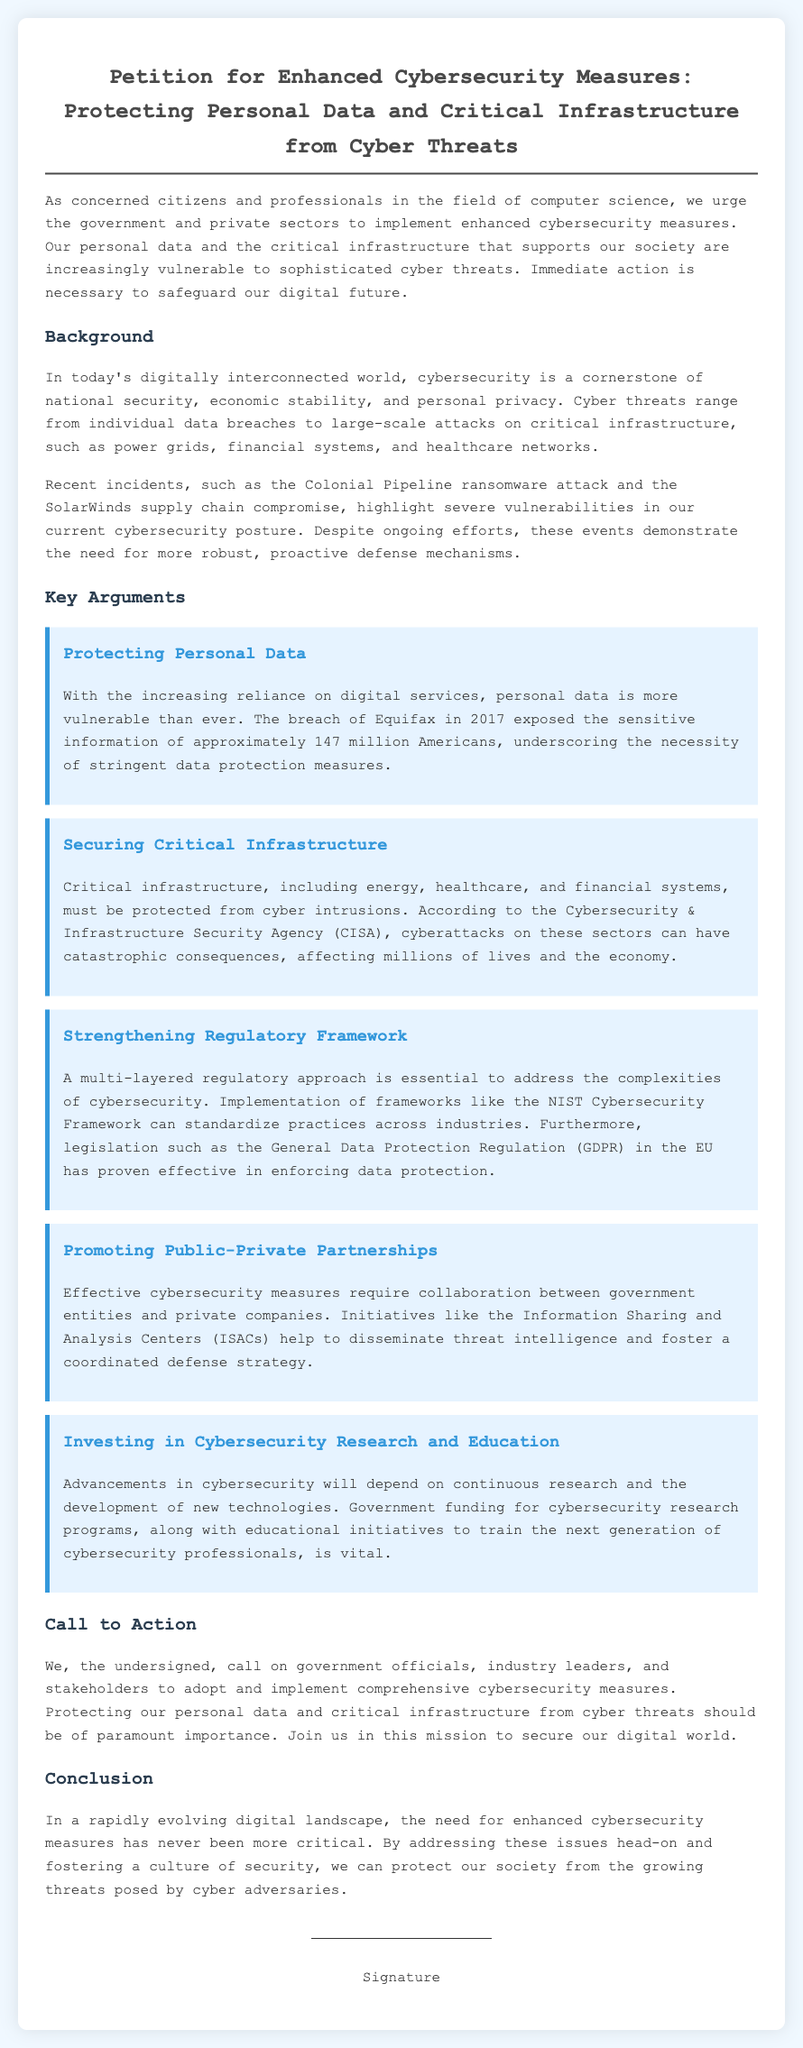What is the title of the petition? The title summarizes the main focus of the document and is stated at the beginning.
Answer: Petition for Enhanced Cybersecurity Measures: Protecting Personal Data and Critical Infrastructure from Cyber Threats What is one recent incident mentioned? The document provides examples of what has highlighted cybersecurity vulnerabilities.
Answer: Colonial Pipeline ransomware attack How many Americans were affected by the Equifax breach? This number illustrates the significant impact of the data breach mentioned in the document.
Answer: Approximately 147 million Who is urged to take action in the petition? The petition calls on specific groups to implement cybersecurity measures.
Answer: Government officials and industry leaders What regulatory framework is mentioned for addressing cybersecurity? This framework serves as a standard for implementing cybersecurity practices.
Answer: NIST Cybersecurity Framework What does CISA stand for? This acronym is introduced in the document when discussing critical infrastructure security.
Answer: Cybersecurity & Infrastructure Security Agency What kind of partnerships are promoted for effective cybersecurity? The document highlights a collaborative approach to enhance cybersecurity measures.
Answer: Public-Private Partnerships What is identified as a crucial aspect of advancing cybersecurity? This refers to the ongoing support needed for future developments in the field.
Answer: Investing in Cybersecurity Research and Education 